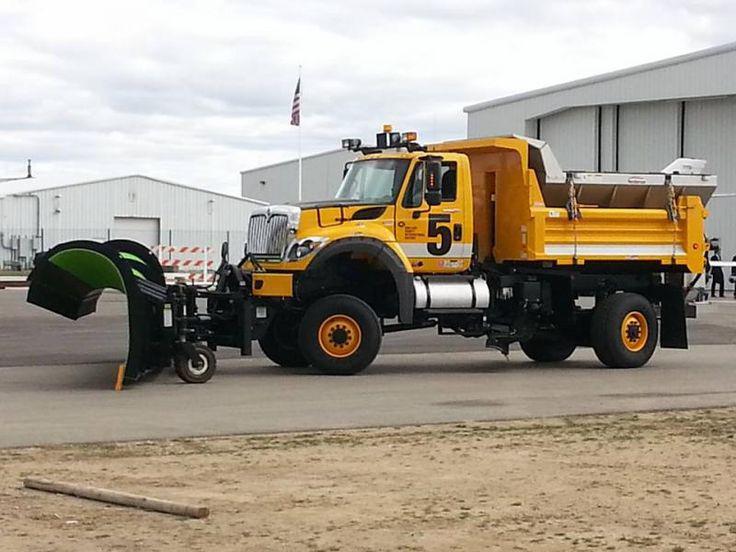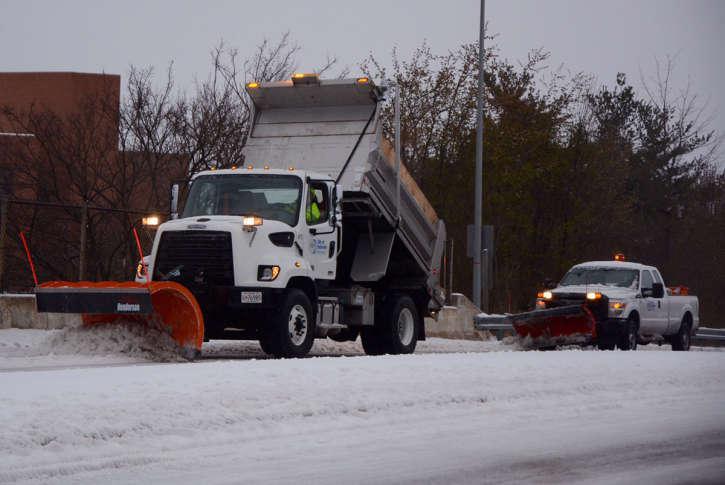The first image is the image on the left, the second image is the image on the right. Examine the images to the left and right. Is the description "An image shows multiple trucks with golden-yellow cabs and beds parked in a dry paved area." accurate? Answer yes or no. No. The first image is the image on the left, the second image is the image on the right. Analyze the images presented: Is the assertion "There are two bulldozers both facing left." valid? Answer yes or no. Yes. 